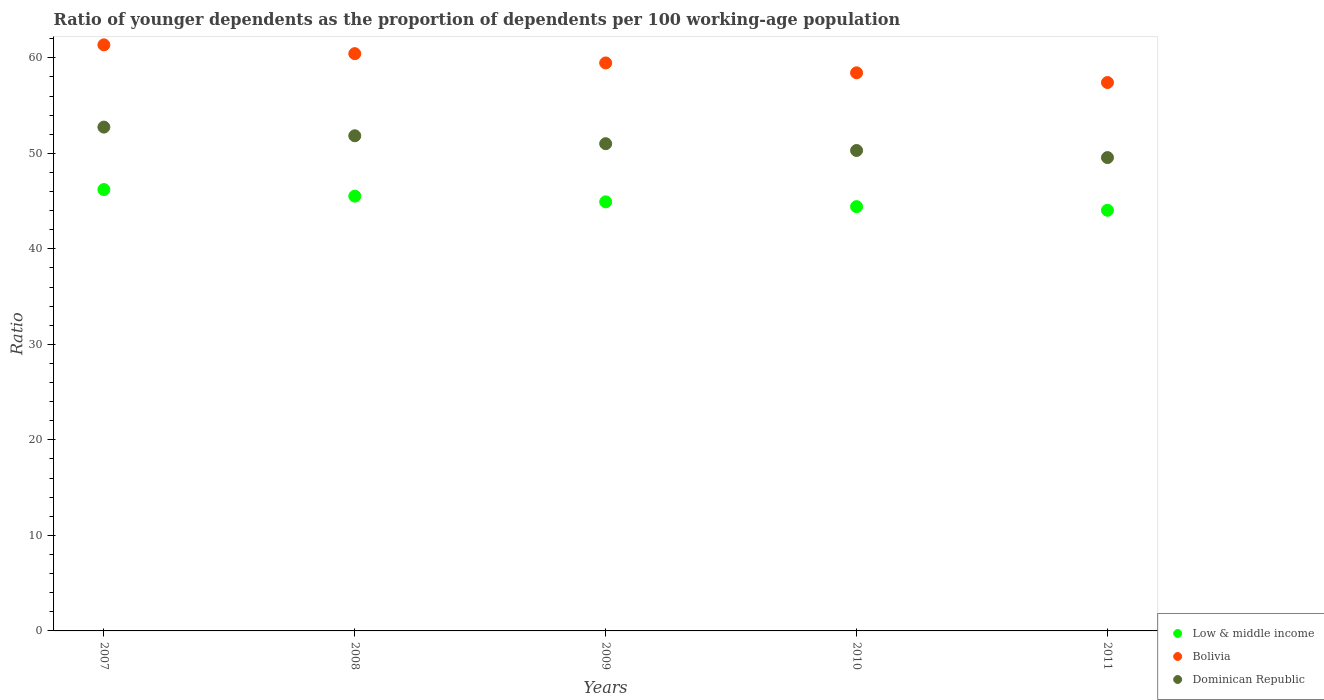What is the age dependency ratio(young) in Bolivia in 2011?
Make the answer very short. 57.41. Across all years, what is the maximum age dependency ratio(young) in Dominican Republic?
Ensure brevity in your answer.  52.75. Across all years, what is the minimum age dependency ratio(young) in Bolivia?
Offer a terse response. 57.41. In which year was the age dependency ratio(young) in Dominican Republic minimum?
Keep it short and to the point. 2011. What is the total age dependency ratio(young) in Dominican Republic in the graph?
Provide a short and direct response. 255.45. What is the difference between the age dependency ratio(young) in Bolivia in 2007 and that in 2010?
Provide a short and direct response. 2.93. What is the difference between the age dependency ratio(young) in Low & middle income in 2007 and the age dependency ratio(young) in Dominican Republic in 2008?
Your answer should be compact. -5.63. What is the average age dependency ratio(young) in Dominican Republic per year?
Offer a terse response. 51.09. In the year 2011, what is the difference between the age dependency ratio(young) in Low & middle income and age dependency ratio(young) in Dominican Republic?
Your answer should be compact. -5.52. What is the ratio of the age dependency ratio(young) in Low & middle income in 2007 to that in 2011?
Offer a terse response. 1.05. Is the age dependency ratio(young) in Low & middle income in 2009 less than that in 2011?
Your answer should be very brief. No. What is the difference between the highest and the second highest age dependency ratio(young) in Dominican Republic?
Give a very brief answer. 0.91. What is the difference between the highest and the lowest age dependency ratio(young) in Bolivia?
Your response must be concise. 3.94. Is it the case that in every year, the sum of the age dependency ratio(young) in Bolivia and age dependency ratio(young) in Dominican Republic  is greater than the age dependency ratio(young) in Low & middle income?
Offer a very short reply. Yes. Is the age dependency ratio(young) in Bolivia strictly greater than the age dependency ratio(young) in Low & middle income over the years?
Provide a short and direct response. Yes. Is the age dependency ratio(young) in Bolivia strictly less than the age dependency ratio(young) in Low & middle income over the years?
Your response must be concise. No. How many years are there in the graph?
Provide a succinct answer. 5. What is the difference between two consecutive major ticks on the Y-axis?
Your answer should be very brief. 10. Are the values on the major ticks of Y-axis written in scientific E-notation?
Offer a very short reply. No. How many legend labels are there?
Your answer should be very brief. 3. What is the title of the graph?
Provide a short and direct response. Ratio of younger dependents as the proportion of dependents per 100 working-age population. What is the label or title of the X-axis?
Provide a short and direct response. Years. What is the label or title of the Y-axis?
Give a very brief answer. Ratio. What is the Ratio in Low & middle income in 2007?
Offer a terse response. 46.21. What is the Ratio in Bolivia in 2007?
Offer a terse response. 61.36. What is the Ratio of Dominican Republic in 2007?
Give a very brief answer. 52.75. What is the Ratio of Low & middle income in 2008?
Your response must be concise. 45.52. What is the Ratio of Bolivia in 2008?
Provide a succinct answer. 60.44. What is the Ratio in Dominican Republic in 2008?
Provide a short and direct response. 51.84. What is the Ratio in Low & middle income in 2009?
Offer a very short reply. 44.92. What is the Ratio of Bolivia in 2009?
Offer a very short reply. 59.46. What is the Ratio in Dominican Republic in 2009?
Make the answer very short. 51.01. What is the Ratio in Low & middle income in 2010?
Your response must be concise. 44.42. What is the Ratio in Bolivia in 2010?
Offer a terse response. 58.43. What is the Ratio of Dominican Republic in 2010?
Ensure brevity in your answer.  50.3. What is the Ratio in Low & middle income in 2011?
Offer a terse response. 44.04. What is the Ratio of Bolivia in 2011?
Offer a very short reply. 57.41. What is the Ratio in Dominican Republic in 2011?
Your response must be concise. 49.56. Across all years, what is the maximum Ratio in Low & middle income?
Keep it short and to the point. 46.21. Across all years, what is the maximum Ratio in Bolivia?
Make the answer very short. 61.36. Across all years, what is the maximum Ratio in Dominican Republic?
Give a very brief answer. 52.75. Across all years, what is the minimum Ratio of Low & middle income?
Offer a very short reply. 44.04. Across all years, what is the minimum Ratio of Bolivia?
Provide a short and direct response. 57.41. Across all years, what is the minimum Ratio of Dominican Republic?
Offer a very short reply. 49.56. What is the total Ratio in Low & middle income in the graph?
Keep it short and to the point. 225.11. What is the total Ratio of Bolivia in the graph?
Your answer should be compact. 297.1. What is the total Ratio of Dominican Republic in the graph?
Provide a succinct answer. 255.45. What is the difference between the Ratio in Low & middle income in 2007 and that in 2008?
Ensure brevity in your answer.  0.69. What is the difference between the Ratio in Bolivia in 2007 and that in 2008?
Keep it short and to the point. 0.92. What is the difference between the Ratio of Dominican Republic in 2007 and that in 2008?
Offer a very short reply. 0.91. What is the difference between the Ratio of Low & middle income in 2007 and that in 2009?
Your answer should be compact. 1.29. What is the difference between the Ratio of Bolivia in 2007 and that in 2009?
Provide a short and direct response. 1.89. What is the difference between the Ratio of Dominican Republic in 2007 and that in 2009?
Make the answer very short. 1.74. What is the difference between the Ratio of Low & middle income in 2007 and that in 2010?
Provide a succinct answer. 1.79. What is the difference between the Ratio of Bolivia in 2007 and that in 2010?
Ensure brevity in your answer.  2.93. What is the difference between the Ratio in Dominican Republic in 2007 and that in 2010?
Offer a very short reply. 2.45. What is the difference between the Ratio of Low & middle income in 2007 and that in 2011?
Ensure brevity in your answer.  2.17. What is the difference between the Ratio of Bolivia in 2007 and that in 2011?
Offer a very short reply. 3.94. What is the difference between the Ratio in Dominican Republic in 2007 and that in 2011?
Your answer should be compact. 3.19. What is the difference between the Ratio of Low & middle income in 2008 and that in 2009?
Offer a terse response. 0.6. What is the difference between the Ratio of Bolivia in 2008 and that in 2009?
Offer a very short reply. 0.97. What is the difference between the Ratio of Dominican Republic in 2008 and that in 2009?
Your answer should be compact. 0.83. What is the difference between the Ratio in Low & middle income in 2008 and that in 2010?
Your response must be concise. 1.1. What is the difference between the Ratio of Bolivia in 2008 and that in 2010?
Offer a terse response. 2.01. What is the difference between the Ratio of Dominican Republic in 2008 and that in 2010?
Offer a terse response. 1.54. What is the difference between the Ratio in Low & middle income in 2008 and that in 2011?
Provide a short and direct response. 1.48. What is the difference between the Ratio in Bolivia in 2008 and that in 2011?
Provide a succinct answer. 3.02. What is the difference between the Ratio in Dominican Republic in 2008 and that in 2011?
Give a very brief answer. 2.28. What is the difference between the Ratio of Low & middle income in 2009 and that in 2010?
Ensure brevity in your answer.  0.5. What is the difference between the Ratio of Bolivia in 2009 and that in 2010?
Offer a very short reply. 1.03. What is the difference between the Ratio of Dominican Republic in 2009 and that in 2010?
Give a very brief answer. 0.71. What is the difference between the Ratio of Low & middle income in 2009 and that in 2011?
Provide a succinct answer. 0.88. What is the difference between the Ratio of Bolivia in 2009 and that in 2011?
Keep it short and to the point. 2.05. What is the difference between the Ratio of Dominican Republic in 2009 and that in 2011?
Offer a very short reply. 1.45. What is the difference between the Ratio of Low & middle income in 2010 and that in 2011?
Make the answer very short. 0.38. What is the difference between the Ratio in Bolivia in 2010 and that in 2011?
Provide a short and direct response. 1.02. What is the difference between the Ratio of Dominican Republic in 2010 and that in 2011?
Your answer should be compact. 0.74. What is the difference between the Ratio of Low & middle income in 2007 and the Ratio of Bolivia in 2008?
Your response must be concise. -14.23. What is the difference between the Ratio in Low & middle income in 2007 and the Ratio in Dominican Republic in 2008?
Your answer should be compact. -5.63. What is the difference between the Ratio in Bolivia in 2007 and the Ratio in Dominican Republic in 2008?
Your answer should be compact. 9.52. What is the difference between the Ratio in Low & middle income in 2007 and the Ratio in Bolivia in 2009?
Provide a succinct answer. -13.26. What is the difference between the Ratio of Low & middle income in 2007 and the Ratio of Dominican Republic in 2009?
Make the answer very short. -4.8. What is the difference between the Ratio of Bolivia in 2007 and the Ratio of Dominican Republic in 2009?
Keep it short and to the point. 10.35. What is the difference between the Ratio of Low & middle income in 2007 and the Ratio of Bolivia in 2010?
Give a very brief answer. -12.22. What is the difference between the Ratio of Low & middle income in 2007 and the Ratio of Dominican Republic in 2010?
Your response must be concise. -4.09. What is the difference between the Ratio in Bolivia in 2007 and the Ratio in Dominican Republic in 2010?
Offer a terse response. 11.06. What is the difference between the Ratio of Low & middle income in 2007 and the Ratio of Bolivia in 2011?
Keep it short and to the point. -11.21. What is the difference between the Ratio in Low & middle income in 2007 and the Ratio in Dominican Republic in 2011?
Keep it short and to the point. -3.35. What is the difference between the Ratio in Bolivia in 2007 and the Ratio in Dominican Republic in 2011?
Your response must be concise. 11.8. What is the difference between the Ratio in Low & middle income in 2008 and the Ratio in Bolivia in 2009?
Your response must be concise. -13.95. What is the difference between the Ratio of Low & middle income in 2008 and the Ratio of Dominican Republic in 2009?
Offer a terse response. -5.49. What is the difference between the Ratio of Bolivia in 2008 and the Ratio of Dominican Republic in 2009?
Your response must be concise. 9.43. What is the difference between the Ratio in Low & middle income in 2008 and the Ratio in Bolivia in 2010?
Offer a terse response. -12.91. What is the difference between the Ratio of Low & middle income in 2008 and the Ratio of Dominican Republic in 2010?
Give a very brief answer. -4.78. What is the difference between the Ratio in Bolivia in 2008 and the Ratio in Dominican Republic in 2010?
Offer a terse response. 10.14. What is the difference between the Ratio in Low & middle income in 2008 and the Ratio in Bolivia in 2011?
Provide a succinct answer. -11.89. What is the difference between the Ratio in Low & middle income in 2008 and the Ratio in Dominican Republic in 2011?
Offer a terse response. -4.04. What is the difference between the Ratio of Bolivia in 2008 and the Ratio of Dominican Republic in 2011?
Keep it short and to the point. 10.88. What is the difference between the Ratio in Low & middle income in 2009 and the Ratio in Bolivia in 2010?
Your answer should be compact. -13.51. What is the difference between the Ratio of Low & middle income in 2009 and the Ratio of Dominican Republic in 2010?
Make the answer very short. -5.38. What is the difference between the Ratio in Bolivia in 2009 and the Ratio in Dominican Republic in 2010?
Offer a terse response. 9.17. What is the difference between the Ratio of Low & middle income in 2009 and the Ratio of Bolivia in 2011?
Offer a very short reply. -12.49. What is the difference between the Ratio in Low & middle income in 2009 and the Ratio in Dominican Republic in 2011?
Offer a very short reply. -4.63. What is the difference between the Ratio of Bolivia in 2009 and the Ratio of Dominican Republic in 2011?
Offer a terse response. 9.91. What is the difference between the Ratio in Low & middle income in 2010 and the Ratio in Bolivia in 2011?
Give a very brief answer. -12.99. What is the difference between the Ratio in Low & middle income in 2010 and the Ratio in Dominican Republic in 2011?
Ensure brevity in your answer.  -5.14. What is the difference between the Ratio of Bolivia in 2010 and the Ratio of Dominican Republic in 2011?
Provide a succinct answer. 8.87. What is the average Ratio of Low & middle income per year?
Make the answer very short. 45.02. What is the average Ratio in Bolivia per year?
Offer a terse response. 59.42. What is the average Ratio in Dominican Republic per year?
Ensure brevity in your answer.  51.09. In the year 2007, what is the difference between the Ratio in Low & middle income and Ratio in Bolivia?
Your answer should be compact. -15.15. In the year 2007, what is the difference between the Ratio in Low & middle income and Ratio in Dominican Republic?
Offer a very short reply. -6.54. In the year 2007, what is the difference between the Ratio of Bolivia and Ratio of Dominican Republic?
Your answer should be compact. 8.61. In the year 2008, what is the difference between the Ratio in Low & middle income and Ratio in Bolivia?
Ensure brevity in your answer.  -14.92. In the year 2008, what is the difference between the Ratio in Low & middle income and Ratio in Dominican Republic?
Offer a very short reply. -6.32. In the year 2008, what is the difference between the Ratio in Bolivia and Ratio in Dominican Republic?
Your answer should be compact. 8.6. In the year 2009, what is the difference between the Ratio in Low & middle income and Ratio in Bolivia?
Your response must be concise. -14.54. In the year 2009, what is the difference between the Ratio of Low & middle income and Ratio of Dominican Republic?
Give a very brief answer. -6.09. In the year 2009, what is the difference between the Ratio of Bolivia and Ratio of Dominican Republic?
Your answer should be compact. 8.45. In the year 2010, what is the difference between the Ratio in Low & middle income and Ratio in Bolivia?
Provide a short and direct response. -14.01. In the year 2010, what is the difference between the Ratio in Low & middle income and Ratio in Dominican Republic?
Provide a short and direct response. -5.88. In the year 2010, what is the difference between the Ratio in Bolivia and Ratio in Dominican Republic?
Your answer should be very brief. 8.13. In the year 2011, what is the difference between the Ratio of Low & middle income and Ratio of Bolivia?
Provide a succinct answer. -13.38. In the year 2011, what is the difference between the Ratio in Low & middle income and Ratio in Dominican Republic?
Offer a very short reply. -5.52. In the year 2011, what is the difference between the Ratio in Bolivia and Ratio in Dominican Republic?
Keep it short and to the point. 7.86. What is the ratio of the Ratio in Low & middle income in 2007 to that in 2008?
Your response must be concise. 1.02. What is the ratio of the Ratio of Bolivia in 2007 to that in 2008?
Your answer should be compact. 1.02. What is the ratio of the Ratio in Dominican Republic in 2007 to that in 2008?
Provide a short and direct response. 1.02. What is the ratio of the Ratio in Low & middle income in 2007 to that in 2009?
Offer a very short reply. 1.03. What is the ratio of the Ratio of Bolivia in 2007 to that in 2009?
Give a very brief answer. 1.03. What is the ratio of the Ratio in Dominican Republic in 2007 to that in 2009?
Keep it short and to the point. 1.03. What is the ratio of the Ratio in Low & middle income in 2007 to that in 2010?
Your response must be concise. 1.04. What is the ratio of the Ratio of Bolivia in 2007 to that in 2010?
Make the answer very short. 1.05. What is the ratio of the Ratio of Dominican Republic in 2007 to that in 2010?
Ensure brevity in your answer.  1.05. What is the ratio of the Ratio of Low & middle income in 2007 to that in 2011?
Your response must be concise. 1.05. What is the ratio of the Ratio in Bolivia in 2007 to that in 2011?
Offer a terse response. 1.07. What is the ratio of the Ratio in Dominican Republic in 2007 to that in 2011?
Provide a succinct answer. 1.06. What is the ratio of the Ratio of Low & middle income in 2008 to that in 2009?
Your answer should be compact. 1.01. What is the ratio of the Ratio of Bolivia in 2008 to that in 2009?
Provide a succinct answer. 1.02. What is the ratio of the Ratio of Dominican Republic in 2008 to that in 2009?
Your answer should be compact. 1.02. What is the ratio of the Ratio of Low & middle income in 2008 to that in 2010?
Make the answer very short. 1.02. What is the ratio of the Ratio of Bolivia in 2008 to that in 2010?
Provide a short and direct response. 1.03. What is the ratio of the Ratio in Dominican Republic in 2008 to that in 2010?
Your response must be concise. 1.03. What is the ratio of the Ratio of Low & middle income in 2008 to that in 2011?
Provide a short and direct response. 1.03. What is the ratio of the Ratio in Bolivia in 2008 to that in 2011?
Give a very brief answer. 1.05. What is the ratio of the Ratio in Dominican Republic in 2008 to that in 2011?
Keep it short and to the point. 1.05. What is the ratio of the Ratio of Low & middle income in 2009 to that in 2010?
Keep it short and to the point. 1.01. What is the ratio of the Ratio in Bolivia in 2009 to that in 2010?
Keep it short and to the point. 1.02. What is the ratio of the Ratio of Dominican Republic in 2009 to that in 2010?
Offer a terse response. 1.01. What is the ratio of the Ratio of Low & middle income in 2009 to that in 2011?
Your answer should be compact. 1.02. What is the ratio of the Ratio in Bolivia in 2009 to that in 2011?
Provide a succinct answer. 1.04. What is the ratio of the Ratio in Dominican Republic in 2009 to that in 2011?
Give a very brief answer. 1.03. What is the ratio of the Ratio of Low & middle income in 2010 to that in 2011?
Give a very brief answer. 1.01. What is the ratio of the Ratio in Bolivia in 2010 to that in 2011?
Make the answer very short. 1.02. What is the ratio of the Ratio in Dominican Republic in 2010 to that in 2011?
Offer a terse response. 1.01. What is the difference between the highest and the second highest Ratio of Low & middle income?
Provide a short and direct response. 0.69. What is the difference between the highest and the second highest Ratio of Bolivia?
Provide a succinct answer. 0.92. What is the difference between the highest and the second highest Ratio of Dominican Republic?
Provide a short and direct response. 0.91. What is the difference between the highest and the lowest Ratio in Low & middle income?
Offer a terse response. 2.17. What is the difference between the highest and the lowest Ratio in Bolivia?
Ensure brevity in your answer.  3.94. What is the difference between the highest and the lowest Ratio of Dominican Republic?
Your answer should be very brief. 3.19. 